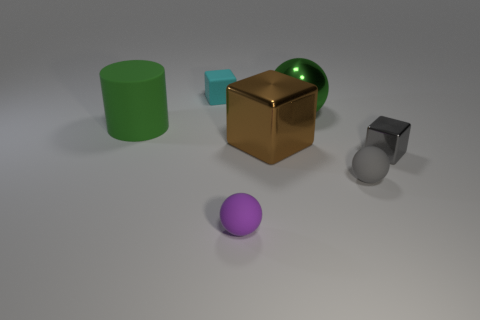Is there anything else that is the same shape as the big green rubber object?
Ensure brevity in your answer.  No. How many rubber objects have the same color as the large shiny sphere?
Your response must be concise. 1. What number of big things are shiny things or purple rubber things?
Keep it short and to the point. 2. There is a matte thing that is the same color as the big metal sphere; what is its size?
Provide a short and direct response. Large. Is there a tiny object that has the same material as the tiny purple sphere?
Give a very brief answer. Yes. There is a big green thing on the left side of the purple rubber ball; what is it made of?
Give a very brief answer. Rubber. Does the rubber object that is on the right side of the purple sphere have the same color as the cube that is on the right side of the large sphere?
Your answer should be compact. Yes. There is a matte cylinder that is the same size as the brown block; what is its color?
Your answer should be compact. Green. What number of other things are there of the same shape as the large rubber thing?
Provide a succinct answer. 0. What size is the matte object to the right of the large metal block?
Your answer should be very brief. Small. 